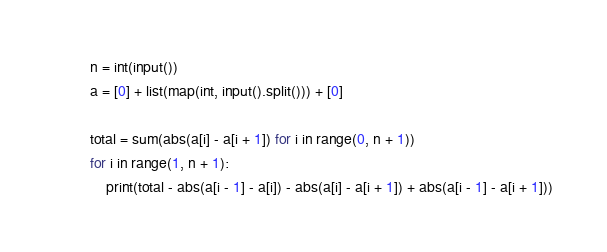Convert code to text. <code><loc_0><loc_0><loc_500><loc_500><_Python_>n = int(input())
a = [0] + list(map(int, input().split())) + [0]

total = sum(abs(a[i] - a[i + 1]) for i in range(0, n + 1))
for i in range(1, n + 1):
    print(total - abs(a[i - 1] - a[i]) - abs(a[i] - a[i + 1]) + abs(a[i - 1] - a[i + 1]))
</code> 